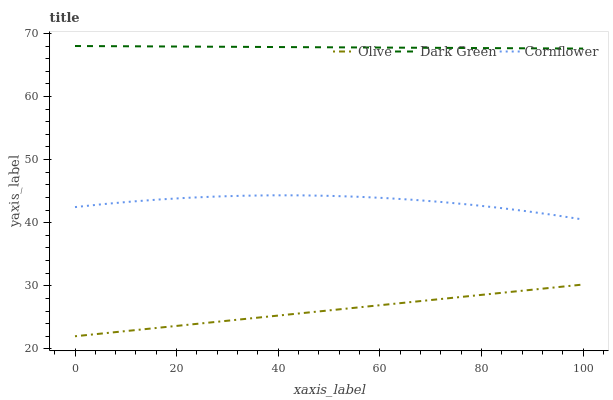Does Olive have the minimum area under the curve?
Answer yes or no. Yes. Does Dark Green have the maximum area under the curve?
Answer yes or no. Yes. Does Cornflower have the minimum area under the curve?
Answer yes or no. No. Does Cornflower have the maximum area under the curve?
Answer yes or no. No. Is Olive the smoothest?
Answer yes or no. Yes. Is Cornflower the roughest?
Answer yes or no. Yes. Is Dark Green the smoothest?
Answer yes or no. No. Is Dark Green the roughest?
Answer yes or no. No. Does Olive have the lowest value?
Answer yes or no. Yes. Does Cornflower have the lowest value?
Answer yes or no. No. Does Dark Green have the highest value?
Answer yes or no. Yes. Does Cornflower have the highest value?
Answer yes or no. No. Is Olive less than Cornflower?
Answer yes or no. Yes. Is Dark Green greater than Cornflower?
Answer yes or no. Yes. Does Olive intersect Cornflower?
Answer yes or no. No. 